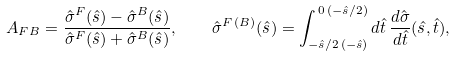<formula> <loc_0><loc_0><loc_500><loc_500>A _ { F B } = \frac { \hat { \sigma } ^ { F } ( \hat { s } ) - \hat { \sigma } ^ { B } ( \hat { s } ) } { \hat { \sigma } ^ { F } ( \hat { s } ) + \hat { \sigma } ^ { B } ( \hat { s } ) } , \quad \hat { \sigma } ^ { F \, ( B ) } ( \hat { s } ) = \int _ { - \hat { s } / 2 \, ( - \hat { s } ) } ^ { \, 0 \, ( - \hat { s } / 2 ) } d \hat { t } \, \frac { d \hat { \sigma } } { d \hat { t } } ( \hat { s } , \hat { t } ) ,</formula> 